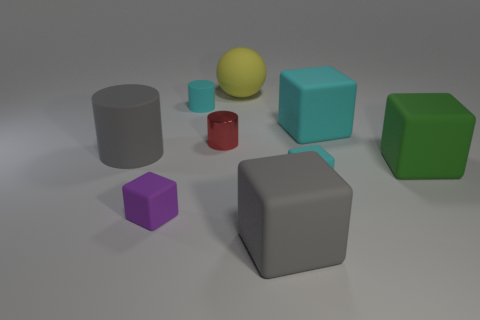There is a tiny cylinder behind the metallic thing in front of the big yellow matte object; are there any small cyan matte blocks in front of it? Although I can see there are various objects in the image, I cannot find any small cyan matte blocks in front of the big yellow matte object. There is a small red cylinder and several blocks of different colors and sizes, but none of them are small, cyan, and matte. 